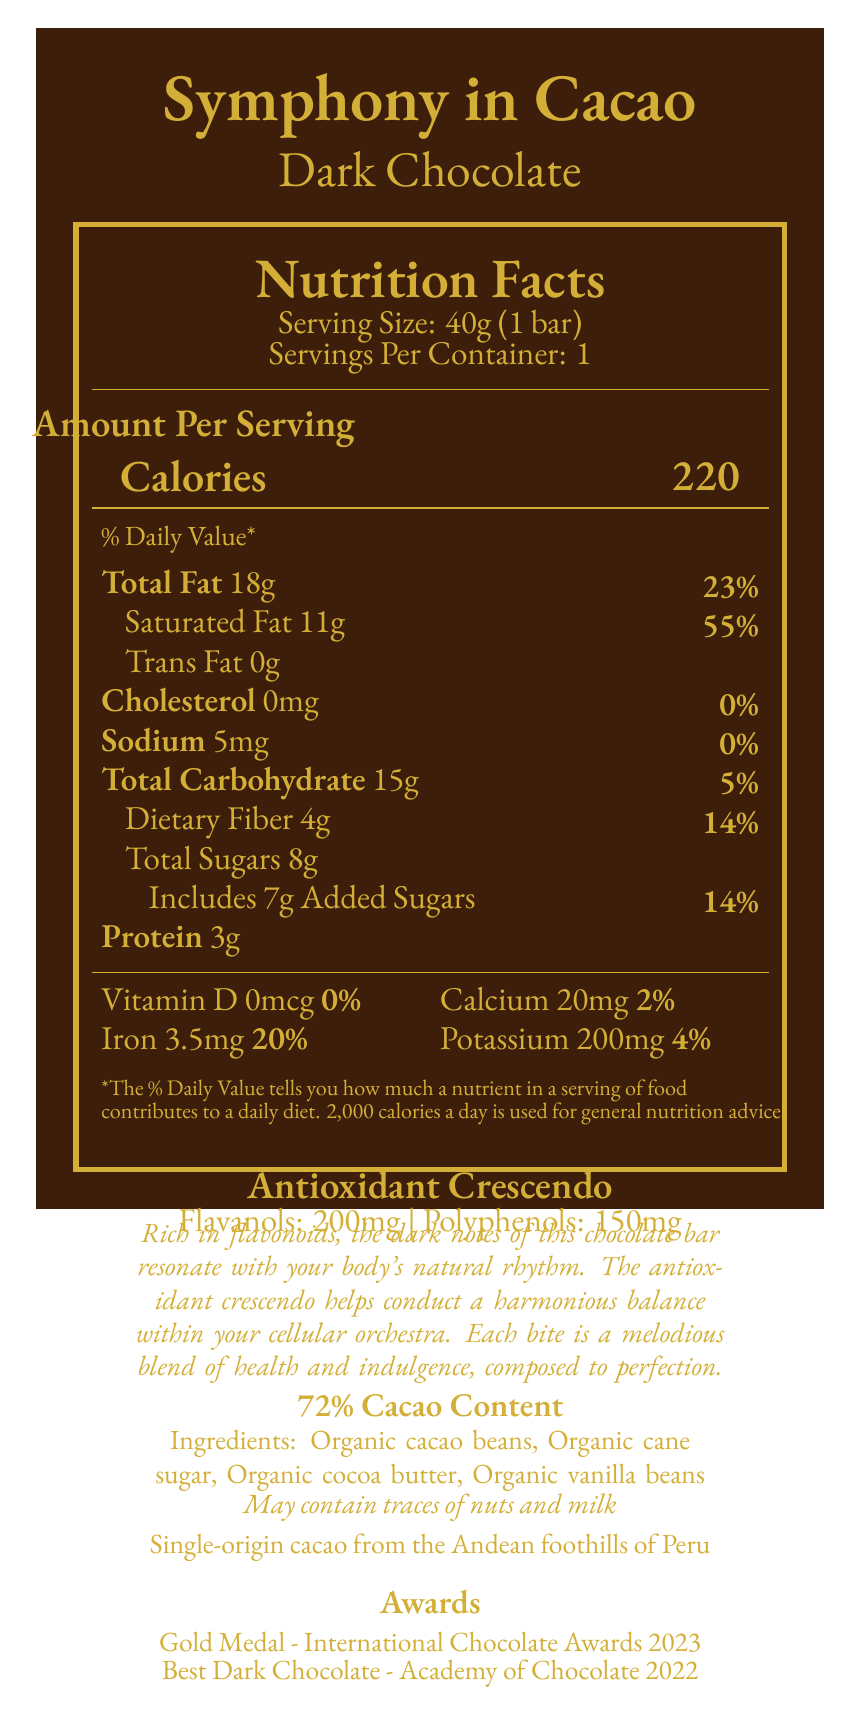what is the serving size of the Symphony in Cacao Dark Chocolate bar? The serving size is clearly stated at the top of the Nutrition Facts section as "Serving Size: 40g (1 bar)".
Answer: 40g (1 bar) how many calories does one serving of the chocolate bar contain? The document lists the calories per serving in the Nutrition Facts section as 220.
Answer: 220 what is the percentage of the daily value for saturated fat in this chocolate bar? The Nutrition Facts section shows that one serving contains 11g of saturated fat, which is 55% of the daily value.
Answer: 55% does the chocolate bar contain any trans fat? The Nutrition Facts section lists "Trans Fat 0g", indicating there is no trans fat in the bar.
Answer: No list three key ingredients in the Symphony in Cacao Dark Chocolate bar. The document's ingredient section lists organic cacao beans, organic cane sugar, and organic cocoa butter as key ingredients.
Answer: Organic cacao beans, Organic cane sugar, Organic cocoa butter what is the cacao content of this dark chocolate bar? The document specifies that the cacao content is 72%.
Answer: 72% how many grams of dietary fiber are in one serving of this chocolate bar? The Nutrition Facts section indicates that there are 4g of dietary fiber per serving.
Answer: 4g which of the following awards has the Symphony in Cacao Dark Chocolate bar won? A. Silver Medal - International Chocolate Awards B. Gold Medal - International Chocolate Awards C. Best Milk Chocolate - Academy of Chocolate D. Best Dark Chocolate - Chocolate Lovers' Awards The Awards section lists a Gold Medal from the International Chocolate Awards among its achievements.
Answer: B. Gold Medal - International Chocolate Awards which health benefit is prominently highlighted for this product? A. High protein content B. Antioxidant properties C. Low calorie D. High vitamin content The Antioxidant Crescendo section highlighs the flavanols and polyphenols content, emphasizing the antioxidant properties.
Answer: B. Antioxidant properties is the Symphony in Cacao Dark Chocolate bar suitable for someone looking to avoid added sugars? The Nutrition Facts indicate that the bar includes 7g of added sugars, which is 14% of the daily value.
Answer: No how much iron does one serving provide in terms of the daily value percentage? The Nutrition Facts section states that one serving contains 3.5mg of iron, which is 20% of the daily value.
Answer: 20% what is the origin of the cacao used in this chocolate bar? The document mentions that the cacao is single-origin from the Andean foothills of Peru.
Answer: Single-origin cacao from the Andean foothills of Peru is this dark chocolate bar a good source of calcium? The Nutrition Facts section shows that one serving contains only 2% of the daily value for calcium, which is considered low.
Answer: No summarize the key aspects of the Symphony in Cacao Dark Chocolate bar described in the document. This summary captures the main idea and key details of the document, including nutritional content, antioxidant properties, origin, ingredients, and awards.
Answer: The Symphony in Cacao Dark Chocolate bar is a gourmet dark chocolate product made from single-origin cacao from the Andean foothills of Peru, with a high cacao content of 72%. It is rich in antioxidants, containing 200mg of flavanols and 150mg of polyphenols. The bar has 220 calories per serving, with significant amounts of fat and added sugars but also provides dietary fiber and iron. It has won several prestigious awards, emphasizing its quality and flavor. Key ingredients include organic cacao beans, organic cane sugar, organic cocoa butter, and organic vanilla beans, with potential traces of nuts and milk. what potential allergens are indicated in this product? The Allergen Info section notes that the product may contain traces of nuts and milk.
Answer: May contain traces of nuts and milk what is the total carbohydrate content per serving, and how does it contribute to the daily value percentage? The Nutrition Facts section states that one serving contains 15g of total carbohydrate, which is 5% of the daily value.
Answer: 15g, 5% how many servings are in one container of this chocolate bar? The document specifies that there is 1 serving per container.
Answer: 1 who composed the music notes included in the label? The document does not provide any information about who composed the musical notes included in the label.
Answer: Cannot be determined 